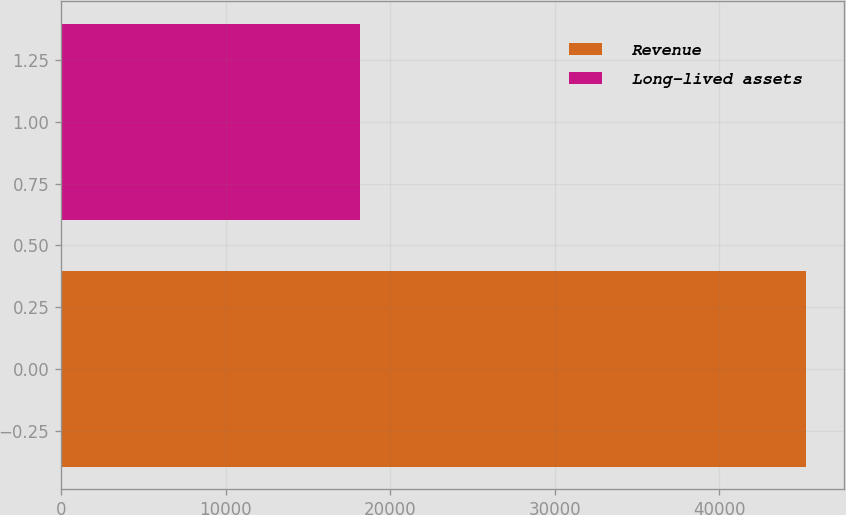<chart> <loc_0><loc_0><loc_500><loc_500><bar_chart><fcel>Revenue<fcel>Long-lived assets<nl><fcel>45309<fcel>18196<nl></chart> 